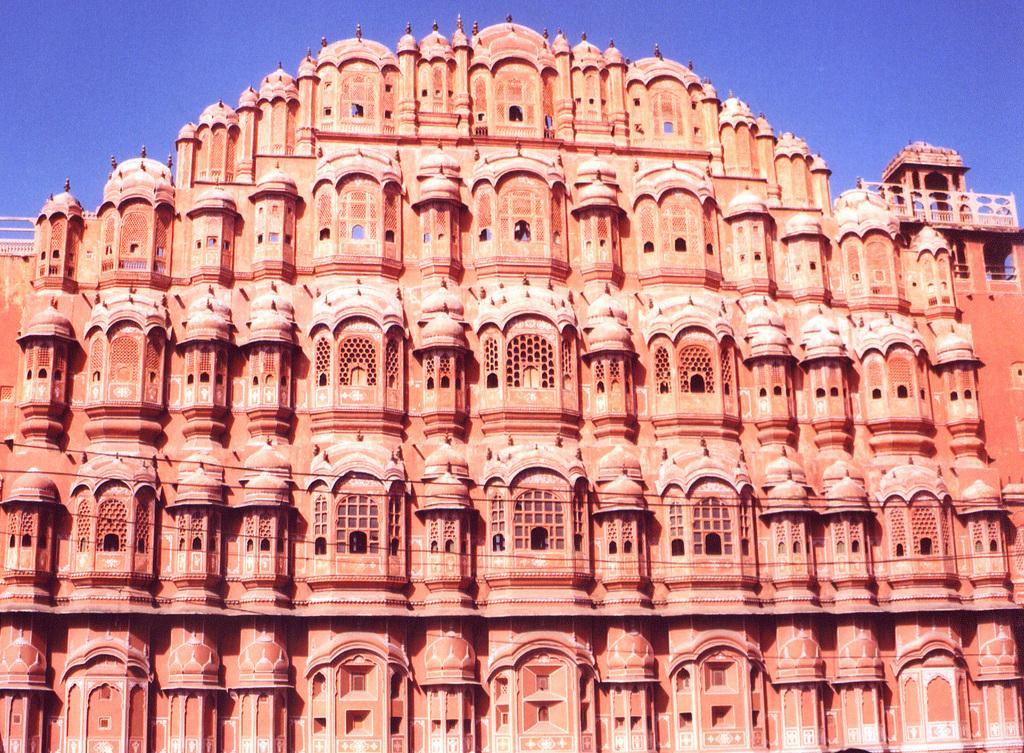Can you describe this image briefly? In this image we can see there is a building. In the background there is a sky. 